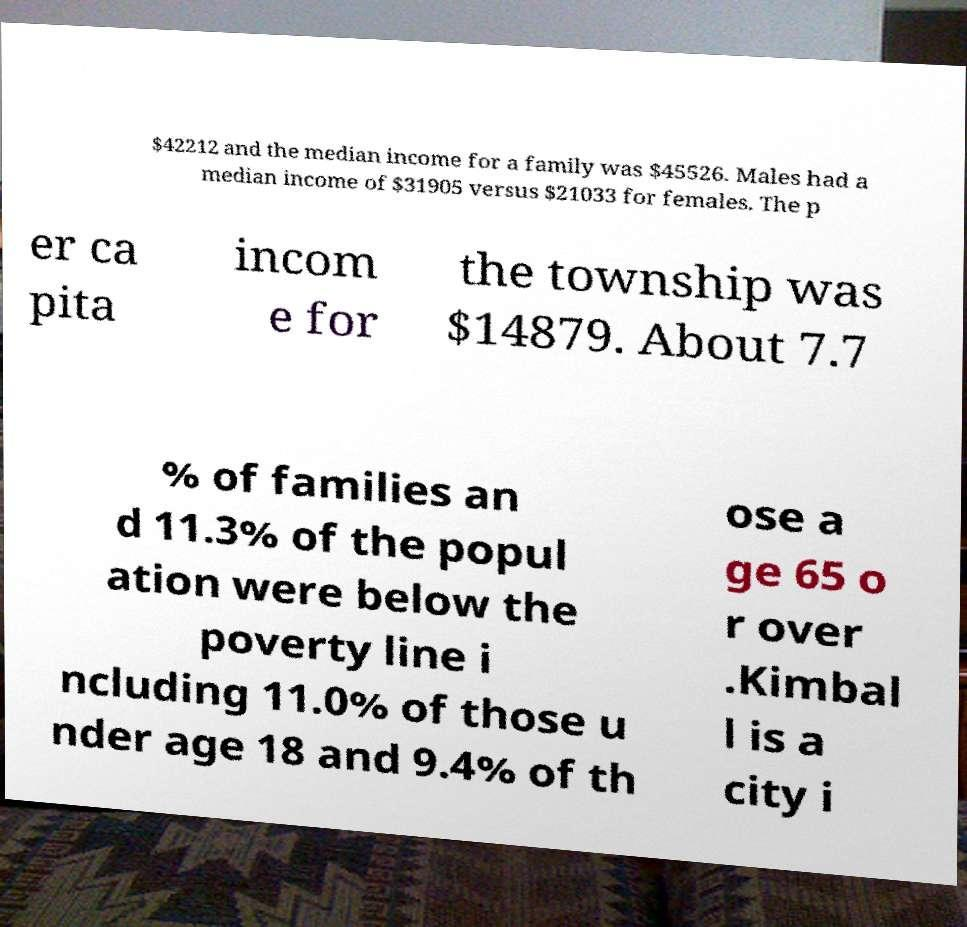Can you read and provide the text displayed in the image?This photo seems to have some interesting text. Can you extract and type it out for me? $42212 and the median income for a family was $45526. Males had a median income of $31905 versus $21033 for females. The p er ca pita incom e for the township was $14879. About 7.7 % of families an d 11.3% of the popul ation were below the poverty line i ncluding 11.0% of those u nder age 18 and 9.4% of th ose a ge 65 o r over .Kimbal l is a city i 